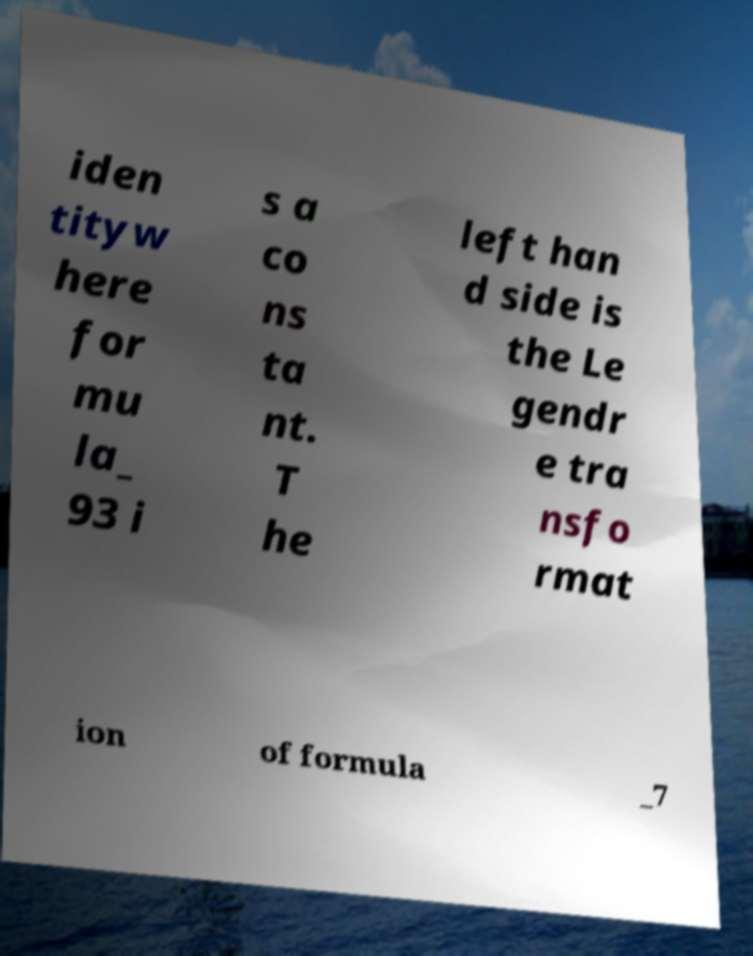There's text embedded in this image that I need extracted. Can you transcribe it verbatim? iden tityw here for mu la_ 93 i s a co ns ta nt. T he left han d side is the Le gendr e tra nsfo rmat ion of formula _7 